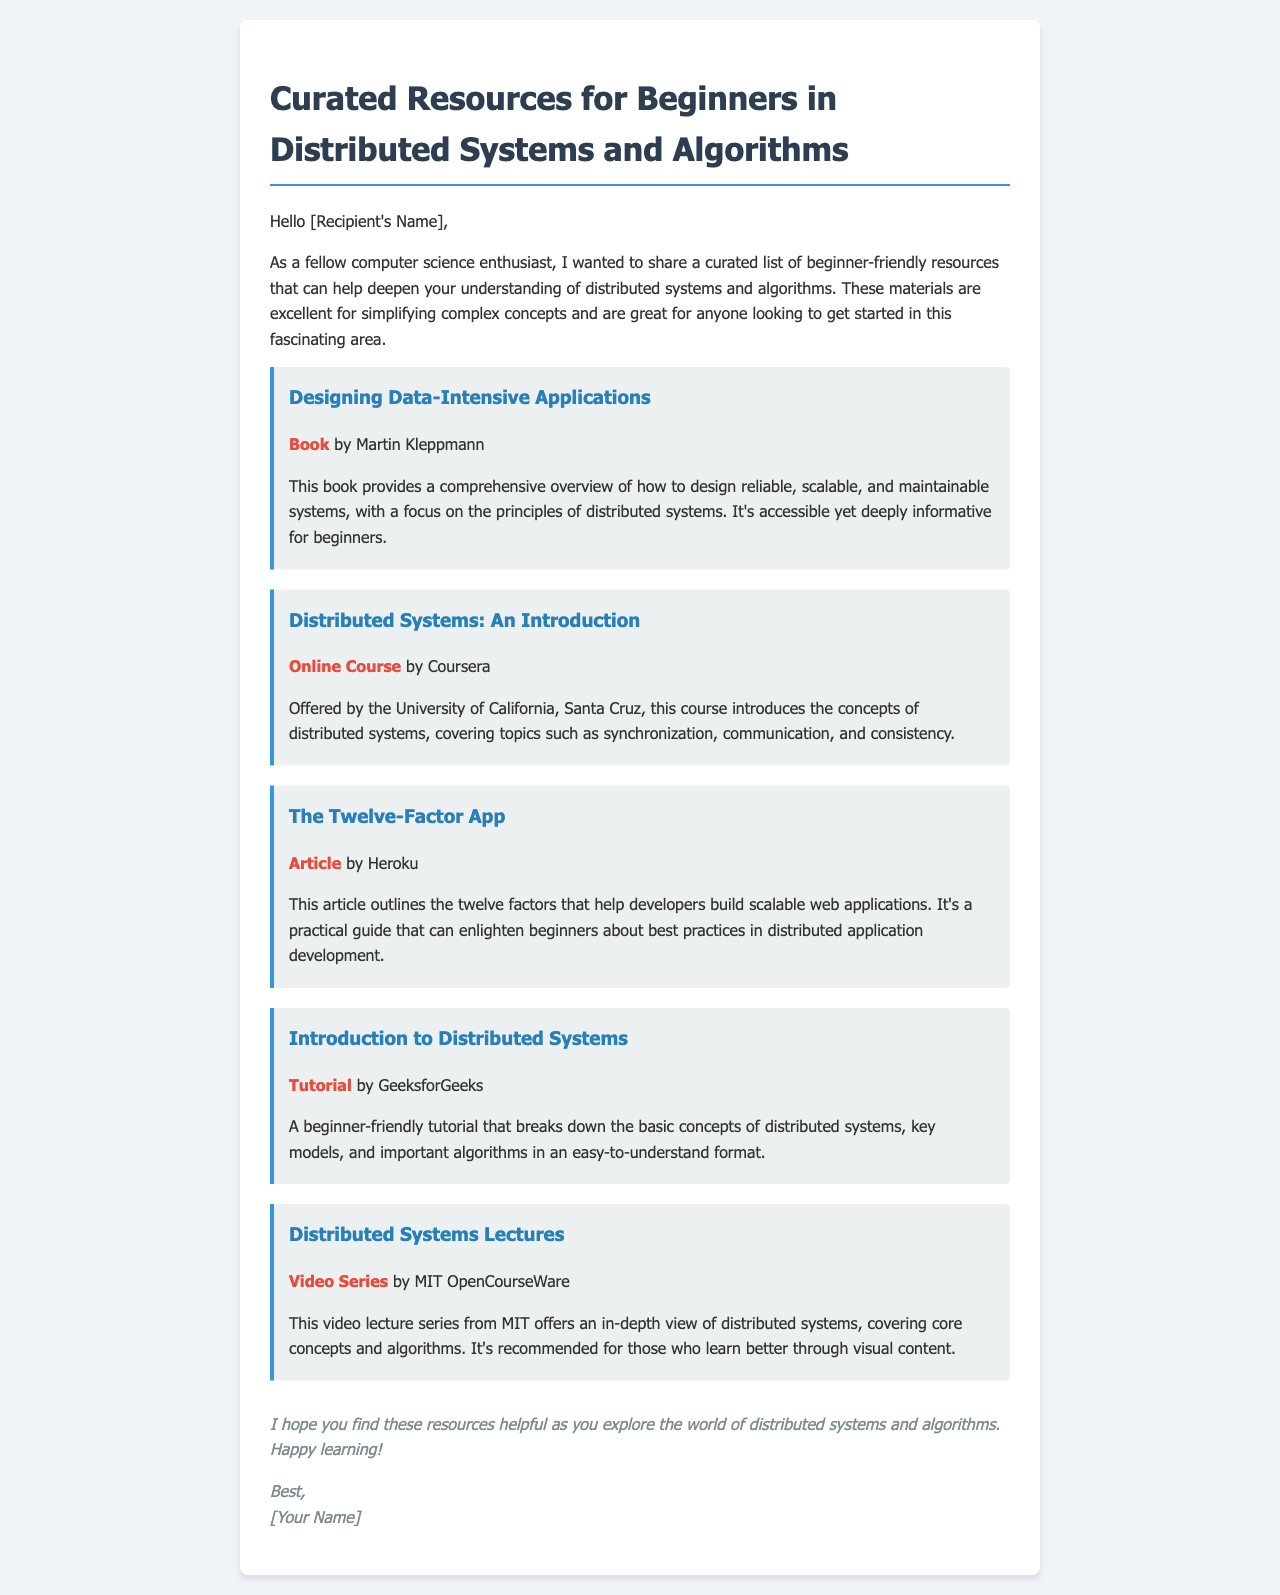What is the title of the first resource? The title of the first resource is the name of the book mentioned at the top of the list, which is "Designing Data-Intensive Applications."
Answer: Designing Data-Intensive Applications Who is the author of the second resource? The second resource is an online course by the University of California, Santa Cruz, and does not have a specific author, but the institution is identified.
Answer: University of California, Santa Cruz What type of resource is "The Twelve-Factor App"? This resource is listed as an article in the document.
Answer: Article How many total resources are mentioned in the email? The document lists a total of five resources focused on distributed systems and algorithms.
Answer: Five What is the primary focus of "Designing Data-Intensive Applications"? The primary focus of this book is on designing reliable, scalable, and maintainable systems in the context of distributed systems.
Answer: Reliable, scalable, and maintainable systems What kind of content does the "Distributed Systems Lectures" resource feature? This specific resource is a video series that offers in-depth coverage of distributed systems topics and algorithms.
Answer: Video series In which format is the "Introduction to Distributed Systems" provided? This resource is provided as a tutorial aimed at beginners.
Answer: Tutorial What is the closing sentiment expressed in the email? The closing sentiment is one of encouragement for further exploration and learning about distributed systems and algorithms.
Answer: Happy learning 